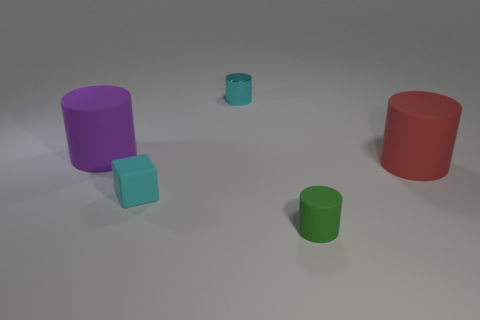Does the big red matte object have the same shape as the matte thing behind the red thing?
Your answer should be very brief. Yes. Are there any large cyan cylinders that have the same material as the large purple object?
Provide a succinct answer. No. Is there a small cylinder behind the cylinder in front of the large red matte object right of the green rubber cylinder?
Offer a terse response. Yes. How many other things are there of the same shape as the purple matte object?
Provide a short and direct response. 3. What color is the rubber object in front of the block in front of the large rubber cylinder to the left of the small cyan metallic cylinder?
Provide a succinct answer. Green. What number of large purple rubber things are there?
Provide a succinct answer. 1. What number of large things are blue rubber blocks or cyan metal objects?
Your answer should be compact. 0. What is the shape of the green thing that is the same size as the cyan metal cylinder?
Give a very brief answer. Cylinder. What is the cylinder that is behind the rubber cylinder that is on the left side of the tiny green rubber object made of?
Provide a succinct answer. Metal. Do the cyan rubber cube and the purple rubber cylinder have the same size?
Your answer should be compact. No. 